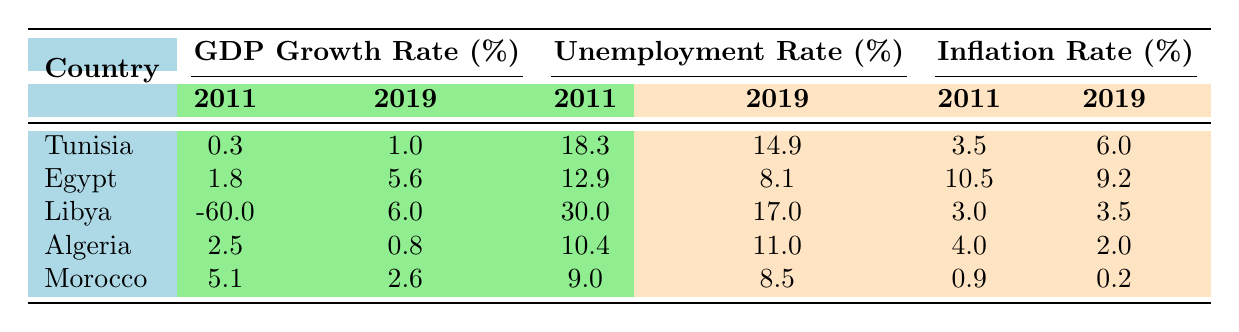What was the GDP growth rate for Libya in 2011? According to the table, Libya's GDP growth rate in 2011 is listed as -60.0%.
Answer: -60.0 Which country had the lowest unemployment rate in 2019? By examining the unemployment rates in 2019, we see that Morocco had the lowest rate at 8.5%.
Answer: Morocco What was the difference in the unemployment rate for Tunisia from 2011 to 2019? To find the difference, subtract Tunisia's unemployment rate in 2019 (14.9%) from 2011 (18.3%), which gives 18.3% - 14.9% = 3.4%.
Answer: 3.4 Is it true that Algeria experienced a decrease in inflation rate from 2011 to 2019? Looking at the inflation rates, Algeria's rate decreased from 4.0% in 2011 to 2.0% in 2019, confirming that this statement is true.
Answer: Yes Which country had the most significant improvement in GDP growth rate from 2011 to 2019? Investigating the GDP growth rates, Libya saw an increase from -60.0% to 6.0%, resulting in a change of 66.0%. This is greater than any other country.
Answer: Libya What was the inflation rate for Egypt in 2011? The table indicates that Egypt's inflation rate in 2011 was 10.5%.
Answer: 10.5 Calculate the average unemployment rate for all countries in 2019. The unemployment rates in 2019 for all countries are: Tunisia (14.9%), Egypt (8.1%), Libya (17.0%), Algeria (11.0%), and Morocco (8.5%). The sum is 14.9 + 8.1 + 17.0 + 11.0 + 8.5 = 59.5%, and dividing by 5 gives an average of 11.9%.
Answer: 11.9 Is it false that Egypt had a higher GDP growth rate than Algeria in 2019? In 2019, Egypt's GDP growth rate was 5.6%, while Algeria's was 0.8%, making the statement false.
Answer: False What is the largest inflation rate recorded in 2019 among the countries listed? The inflation rates for 2019 are: Tunisia (6.0%), Egypt (9.2%), Libya (3.5%), Algeria (2.0%), and Morocco (0.2%). The highest rate is for Egypt at 9.2%.
Answer: 9.2 